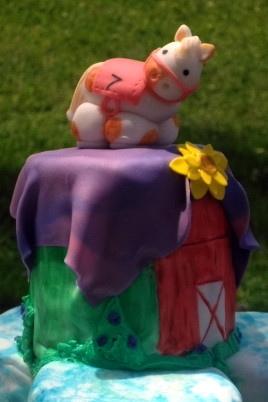What animal is this?
Quick response, please. Horse. Is this a toy?
Be succinct. No. What color is the roof?
Short answer required. Purple. What type of stuffed animal is it?
Short answer required. Horse. What kind of toy is this?
Keep it brief. Cake. What number is on the animal on top?
Keep it brief. 7. How many characters are on the cake?
Answer briefly. 1. 